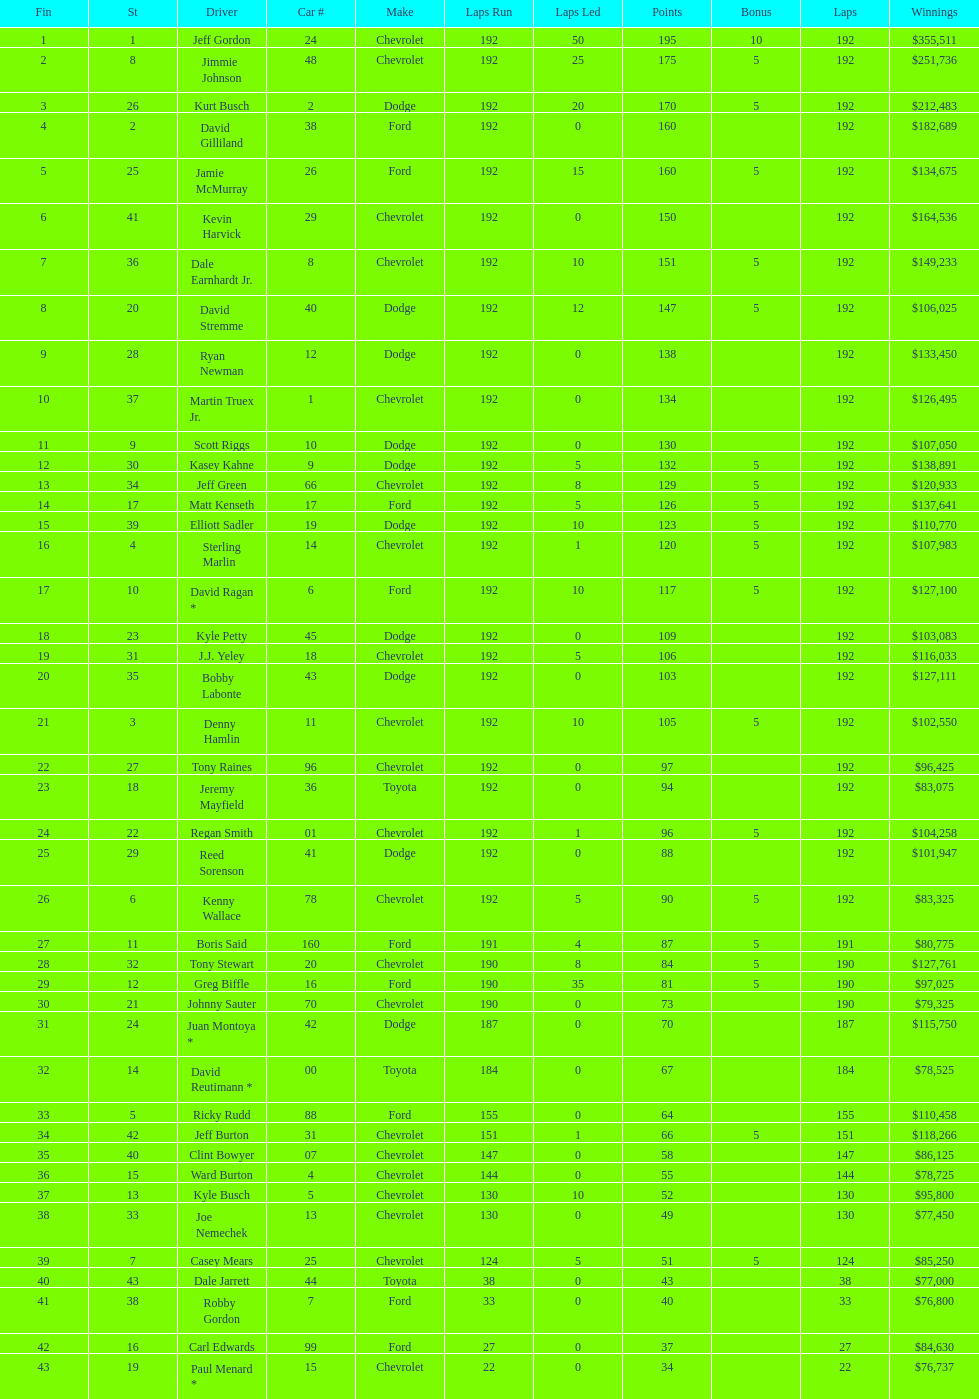Who got the most bonus points? Jeff Gordon. 